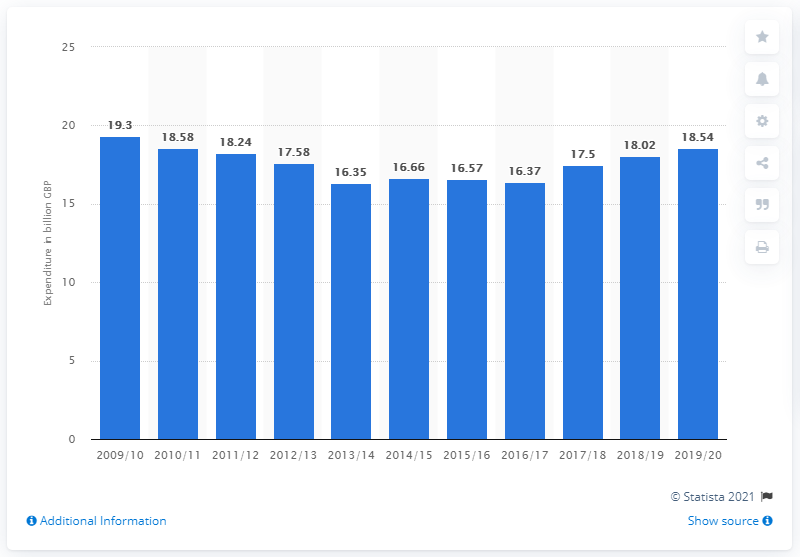Draw attention to some important aspects in this diagram. During the years 2009/10 and 2013/14, a total of 19.3 million pounds was spent on police services by the public sector. 